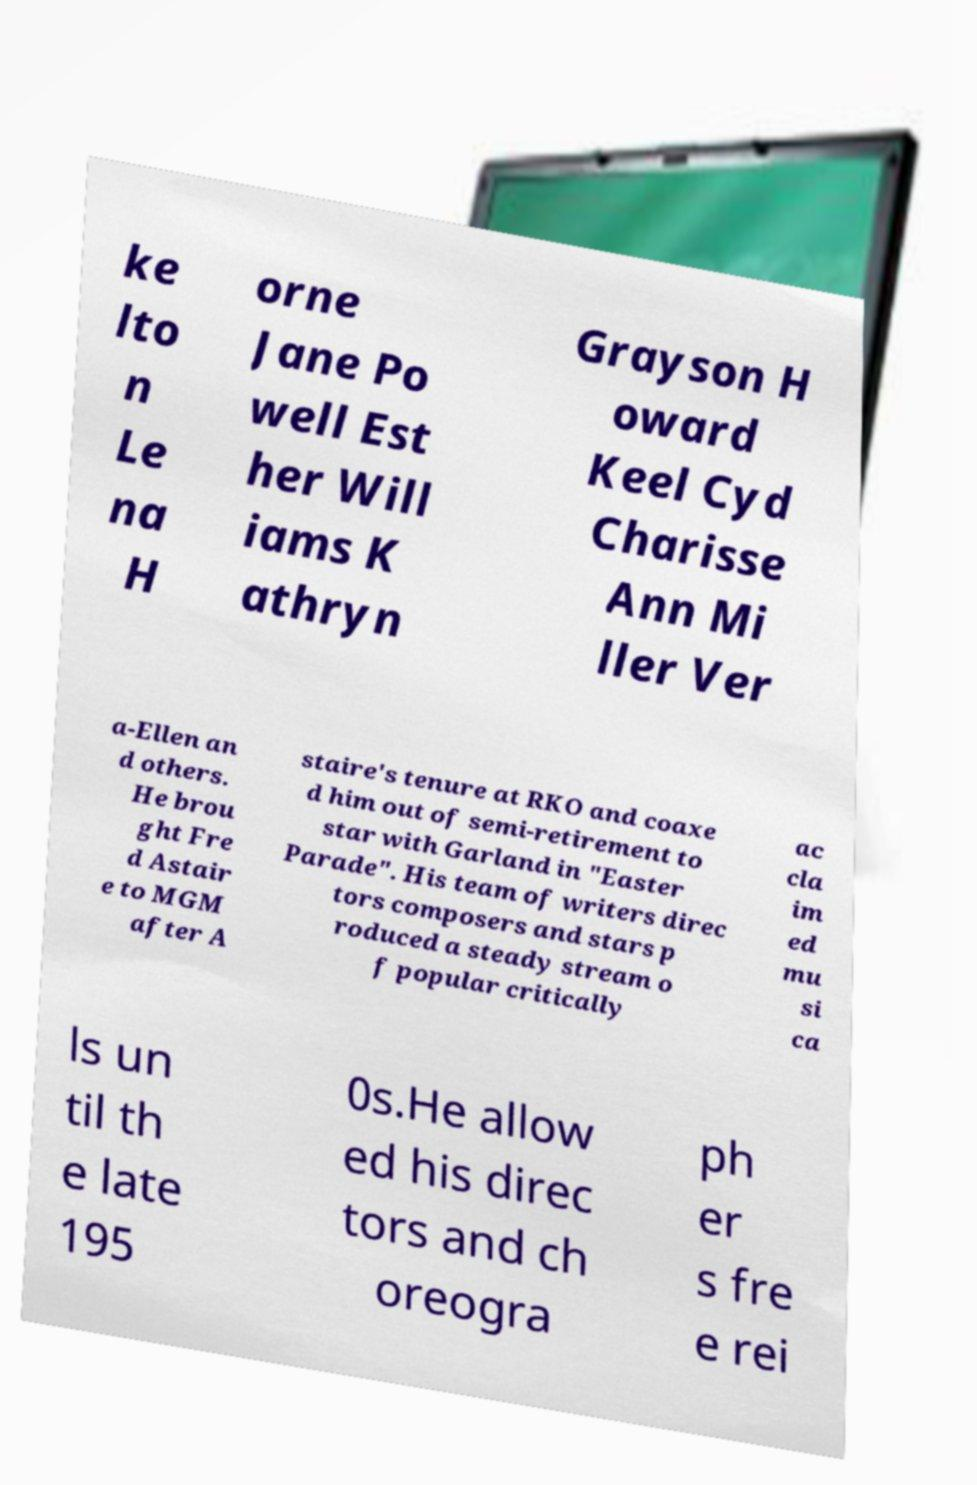I need the written content from this picture converted into text. Can you do that? ke lto n Le na H orne Jane Po well Est her Will iams K athryn Grayson H oward Keel Cyd Charisse Ann Mi ller Ver a-Ellen an d others. He brou ght Fre d Astair e to MGM after A staire's tenure at RKO and coaxe d him out of semi-retirement to star with Garland in "Easter Parade". His team of writers direc tors composers and stars p roduced a steady stream o f popular critically ac cla im ed mu si ca ls un til th e late 195 0s.He allow ed his direc tors and ch oreogra ph er s fre e rei 